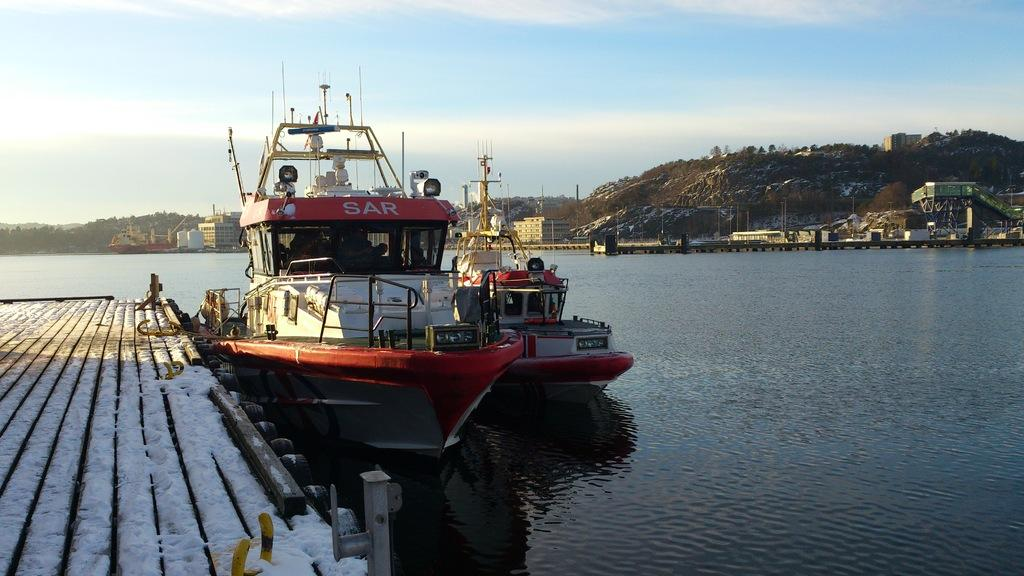<image>
Create a compact narrative representing the image presented. the word SAR is at the top of a bus 